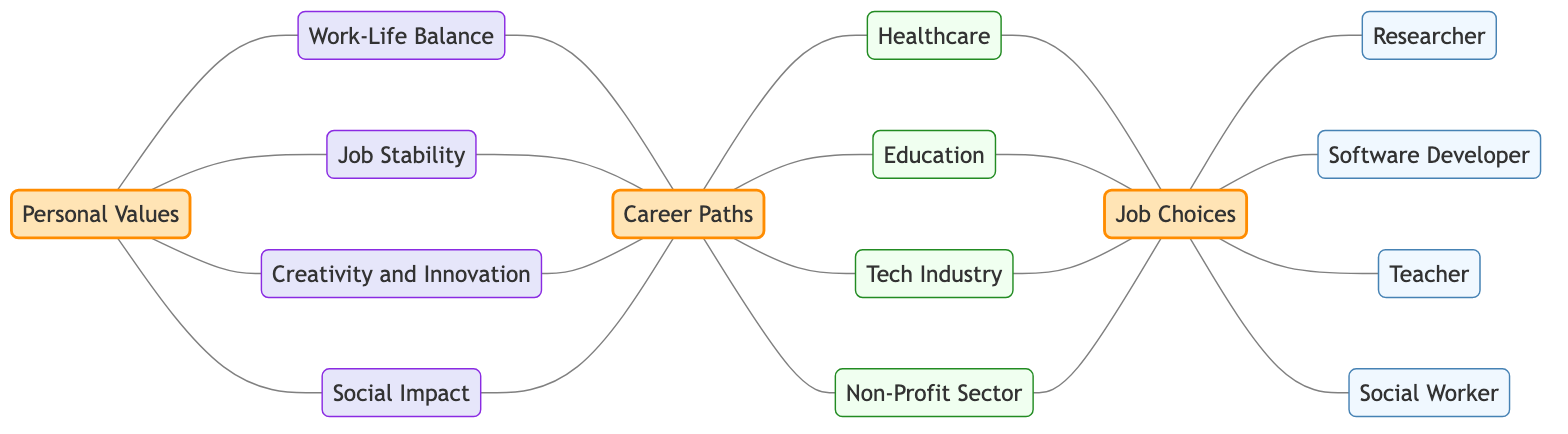What are the four personal values represented in this diagram? The diagram shows four personal values: Work-Life Balance, Job Stability, Creativity and Innovation, and Social Impact. These nodes are directly linked to the Personal Values node.
Answer: Work-Life Balance, Job Stability, Creativity and Innovation, Social Impact How many career paths are represented in the diagram? The career paths connected to the Career Paths node include Healthcare, Education, Tech Industry, and Non-Profit Sector. There are four paths in total.
Answer: 4 Which personal value connects directly to the job choices? The diagram shows that all career paths eventually lead to job choices, but the initial personal values, like Work-Life Balance, Job Stability, Creativity and Innovation, and Social Impact, feed into Career Paths before connecting to job choices. However, they do not connect directly, indicating they influence job choices indirectly.
Answer: None What is the connection between the Tech Industry and job choices? The Tech Industry node is directly linked to the Job Choices node, indicating that it contributes as an option for job choices.
Answer: Job Choices What is the role of 'Career Paths' in relation to 'Personal Values'? The 'Career Paths' node is positioned to illustrate how personal values influence career decisions, creating a pathway from 'Personal Values' to various career options.
Answer: Influence career decisions Which job choice is linked to the Healthcare career path? The Healthcare node connects directly to Job Choices, which signifies that it provides specific job opportunities related to healthcare. The job linked here is Researcher.
Answer: Researcher How many total edges are present in the diagram? Each connection between nodes represents an edge. By counting all the direct connections (edges) made between nodes, we find that there are 20 edges depicted in the diagram.
Answer: 20 Which personal value would suggest a preference for social careers? The Social Impact personal value would suggest a preference for careers that contribute positively to society; it's connected directly to both Personal Values and Career Paths.
Answer: Social Impact What type of diagram does this represent? The diagram displays relationships among nodes in an undirected manner, indicating there’s no specific direction implied among the connections. The connections support an exploration of career paths related to personal values.
Answer: Undirected Graph 